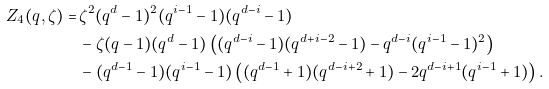Convert formula to latex. <formula><loc_0><loc_0><loc_500><loc_500>Z _ { 4 } ( q , \zeta ) = & \, \zeta ^ { 2 } ( q ^ { d } - 1 ) ^ { 2 } ( q ^ { i - 1 } - 1 ) ( q ^ { d - i } - 1 ) \\ & \, - \zeta ( q - 1 ) ( q ^ { d } - 1 ) \left ( ( q ^ { d - i } - 1 ) ( q ^ { d + i - 2 } - 1 ) - q ^ { d - i } ( q ^ { i - 1 } - 1 ) ^ { 2 } \right ) \\ & \, - ( q ^ { d - 1 } - 1 ) ( q ^ { i - 1 } - 1 ) \left ( ( q ^ { d - 1 } + 1 ) ( q ^ { d - i + 2 } + 1 ) - 2 q ^ { d - i + 1 } ( q ^ { i - 1 } + 1 ) \right ) .</formula> 